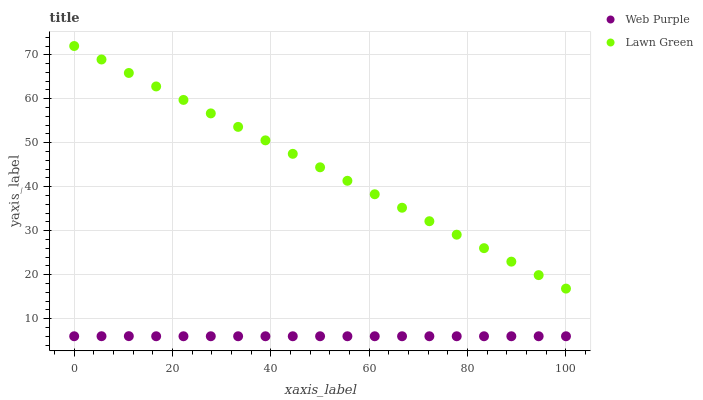Does Web Purple have the minimum area under the curve?
Answer yes or no. Yes. Does Lawn Green have the maximum area under the curve?
Answer yes or no. Yes. Does Web Purple have the maximum area under the curve?
Answer yes or no. No. Is Lawn Green the smoothest?
Answer yes or no. Yes. Is Web Purple the roughest?
Answer yes or no. Yes. Is Web Purple the smoothest?
Answer yes or no. No. Does Web Purple have the lowest value?
Answer yes or no. Yes. Does Lawn Green have the highest value?
Answer yes or no. Yes. Does Web Purple have the highest value?
Answer yes or no. No. Is Web Purple less than Lawn Green?
Answer yes or no. Yes. Is Lawn Green greater than Web Purple?
Answer yes or no. Yes. Does Web Purple intersect Lawn Green?
Answer yes or no. No. 